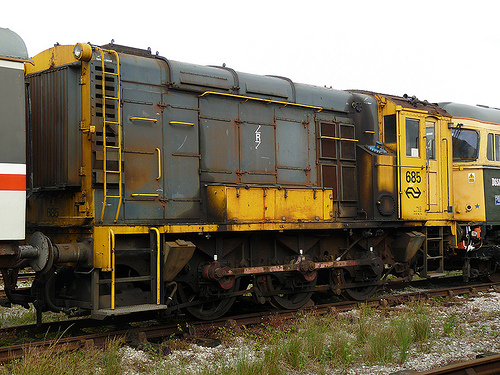What is the vehicle to the left of the ladder on the left? The vehicle to the left of the ladder is a train car. 